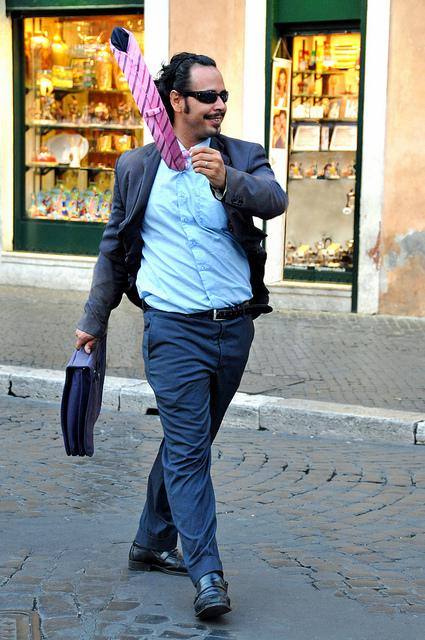What is this man experiencing? wind 